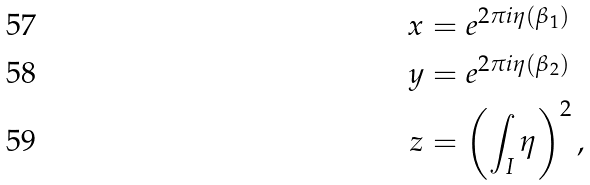Convert formula to latex. <formula><loc_0><loc_0><loc_500><loc_500>x & = e ^ { 2 \pi i \eta ( \beta _ { 1 } ) } \\ y & = e ^ { 2 \pi i \eta ( \beta _ { 2 } ) } \\ z & = \left ( \int _ { I } \eta \right ) ^ { 2 } ,</formula> 